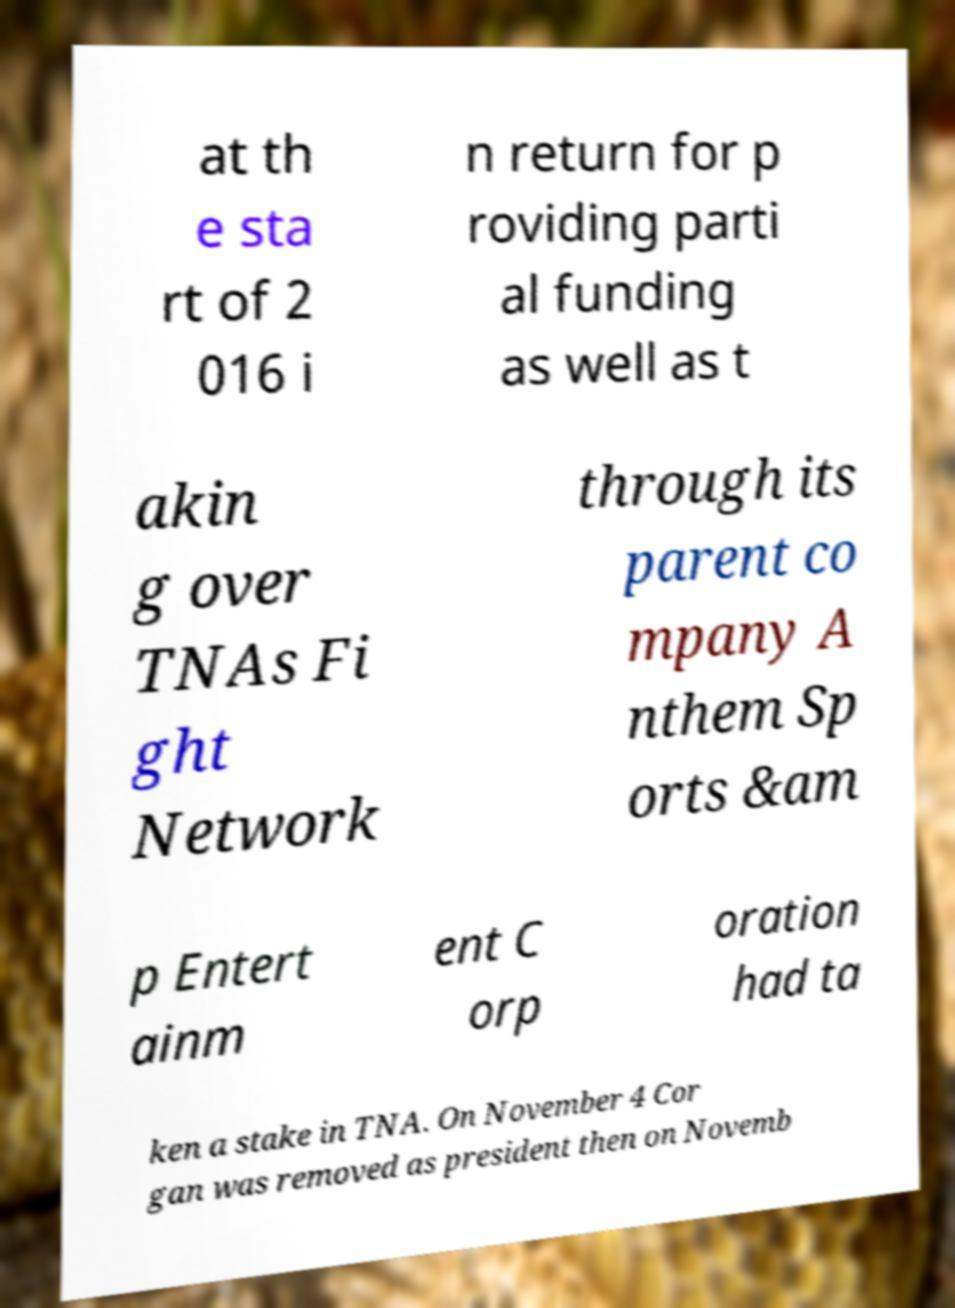For documentation purposes, I need the text within this image transcribed. Could you provide that? at th e sta rt of 2 016 i n return for p roviding parti al funding as well as t akin g over TNAs Fi ght Network through its parent co mpany A nthem Sp orts &am p Entert ainm ent C orp oration had ta ken a stake in TNA. On November 4 Cor gan was removed as president then on Novemb 